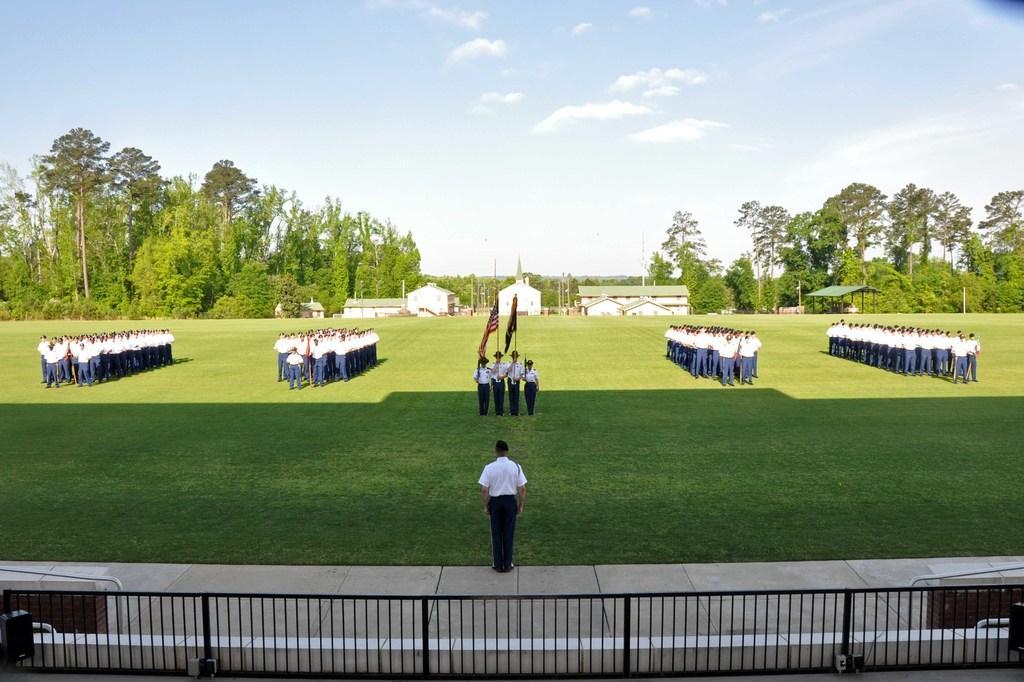Could you give a brief overview of what you see in this image? In this image we can see a few people standing on the ground, among them some people are holding the flags, there are some trees, grass, fence, houses, poles and a shed, in the background we can see the sky with clouds. 